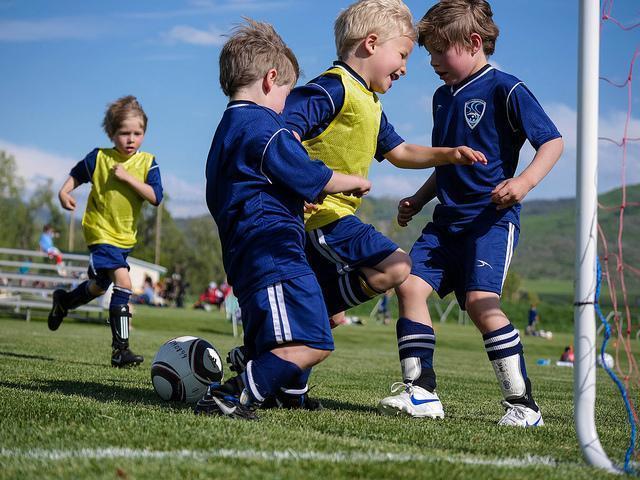How many boys are playing?
Give a very brief answer. 4. How many people can you see?
Give a very brief answer. 4. How many levels does this bus have?
Give a very brief answer. 0. 